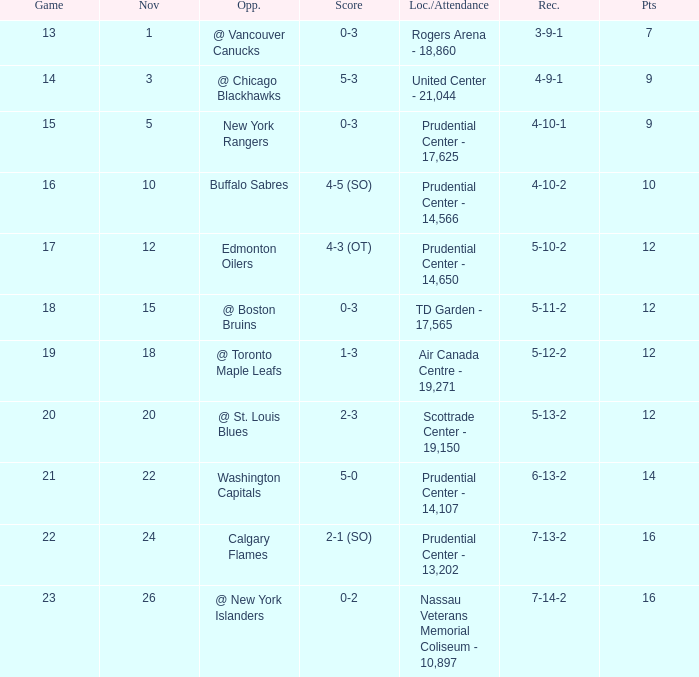What is the milestone that had a 5-3 score? 4-9-1. Can you parse all the data within this table? {'header': ['Game', 'Nov', 'Opp.', 'Score', 'Loc./Attendance', 'Rec.', 'Pts'], 'rows': [['13', '1', '@ Vancouver Canucks', '0-3', 'Rogers Arena - 18,860', '3-9-1', '7'], ['14', '3', '@ Chicago Blackhawks', '5-3', 'United Center - 21,044', '4-9-1', '9'], ['15', '5', 'New York Rangers', '0-3', 'Prudential Center - 17,625', '4-10-1', '9'], ['16', '10', 'Buffalo Sabres', '4-5 (SO)', 'Prudential Center - 14,566', '4-10-2', '10'], ['17', '12', 'Edmonton Oilers', '4-3 (OT)', 'Prudential Center - 14,650', '5-10-2', '12'], ['18', '15', '@ Boston Bruins', '0-3', 'TD Garden - 17,565', '5-11-2', '12'], ['19', '18', '@ Toronto Maple Leafs', '1-3', 'Air Canada Centre - 19,271', '5-12-2', '12'], ['20', '20', '@ St. Louis Blues', '2-3', 'Scottrade Center - 19,150', '5-13-2', '12'], ['21', '22', 'Washington Capitals', '5-0', 'Prudential Center - 14,107', '6-13-2', '14'], ['22', '24', 'Calgary Flames', '2-1 (SO)', 'Prudential Center - 13,202', '7-13-2', '16'], ['23', '26', '@ New York Islanders', '0-2', 'Nassau Veterans Memorial Coliseum - 10,897', '7-14-2', '16']]} 